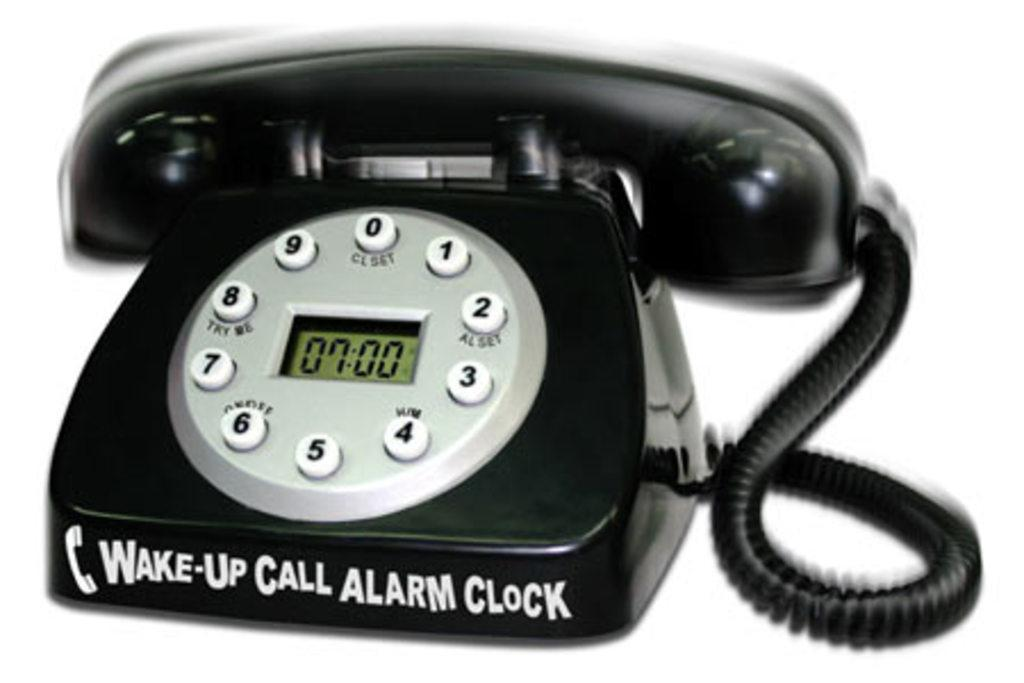<image>
Provide a brief description of the given image. a phone with the words alarm clock on it 